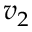Convert formula to latex. <formula><loc_0><loc_0><loc_500><loc_500>v _ { 2 }</formula> 